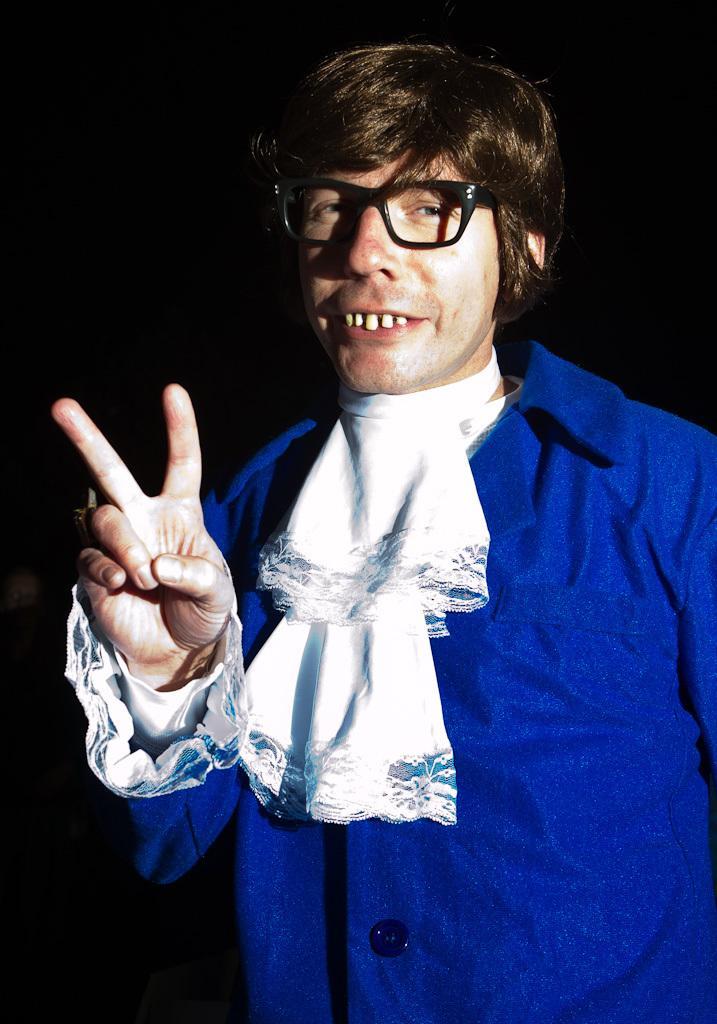How would you summarize this image in a sentence or two? In this image we can see a man and in the background the image is dark. 